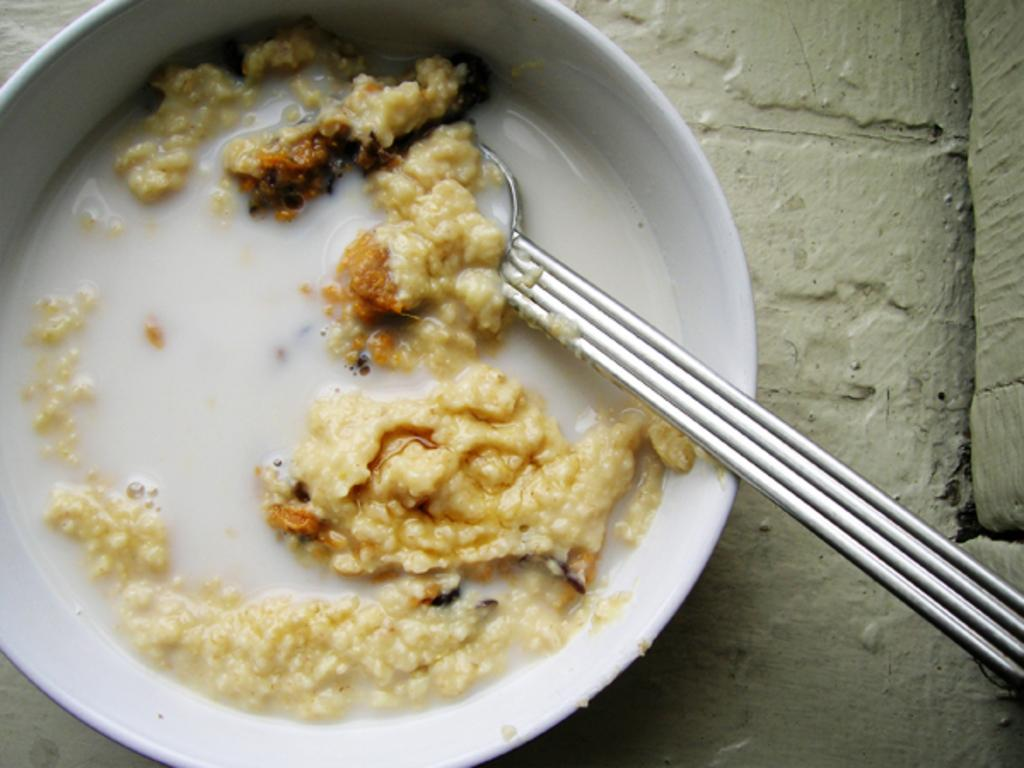What type of food item is visible in the image? There is a food item in the image, but the specific type cannot be determined from the provided facts. What utensil is present in the image? There is a spoon in the image. Where is the spoon located? The spoon is in a bowl. What is the surface beneath the bowl? The bowl is on a concrete surface. What color is the heart-shaped vest in the image? There is no heart-shaped vest present in the image. 